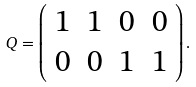<formula> <loc_0><loc_0><loc_500><loc_500>Q = \left ( \begin{array} { c c c c c } 1 & 1 & 0 & 0 \\ 0 & 0 & 1 & 1 \end{array} \right ) .</formula> 